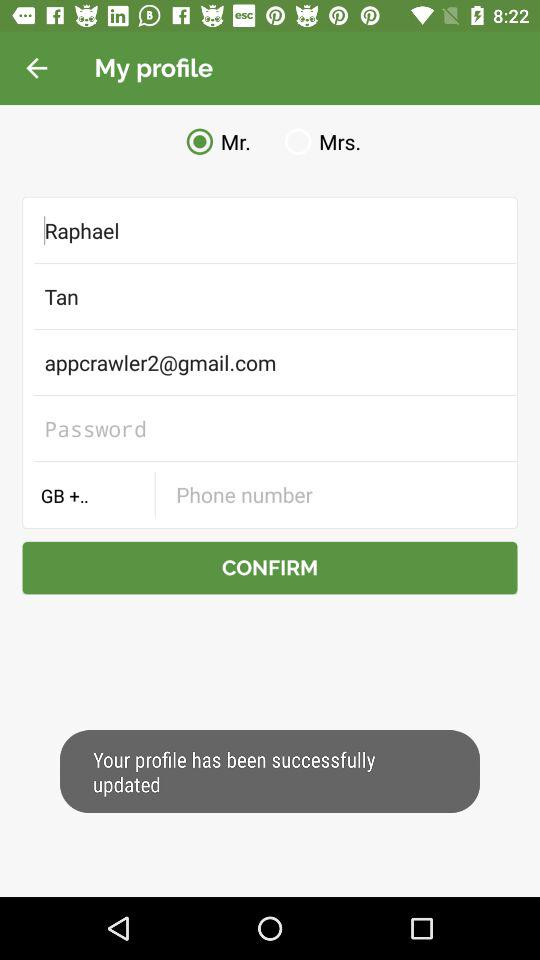What is the app name?
When the provided information is insufficient, respond with <no answer>. <no answer> 